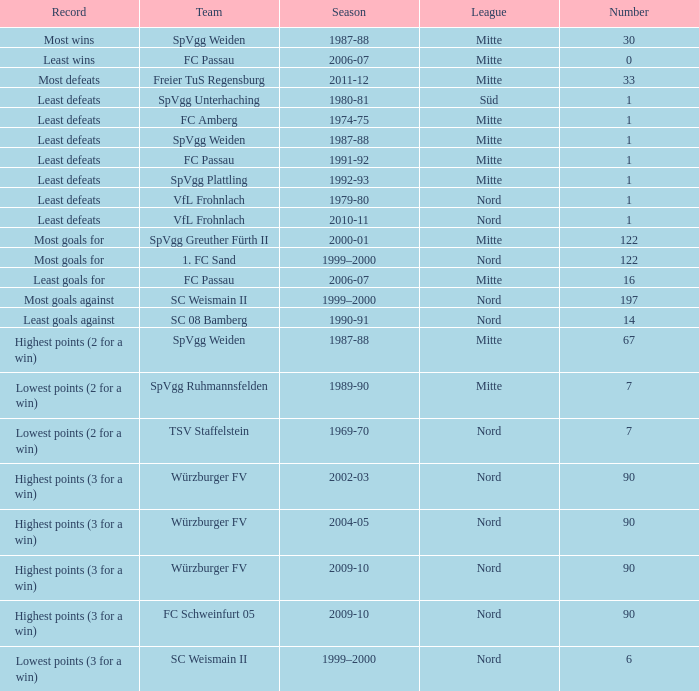What league has most wins as the record? Mitte. 